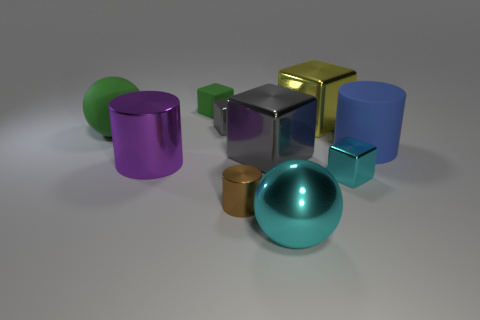Subtract all large shiny cubes. How many cubes are left? 3 Subtract all cyan balls. How many balls are left? 1 Subtract 2 cubes. How many cubes are left? 3 Subtract all purple cylinders. How many cyan cubes are left? 1 Add 5 big gray blocks. How many big gray blocks are left? 6 Add 1 large purple cylinders. How many large purple cylinders exist? 2 Subtract 0 purple blocks. How many objects are left? 10 Subtract all balls. How many objects are left? 8 Subtract all blue cubes. Subtract all red balls. How many cubes are left? 5 Subtract all large gray metallic things. Subtract all cyan objects. How many objects are left? 7 